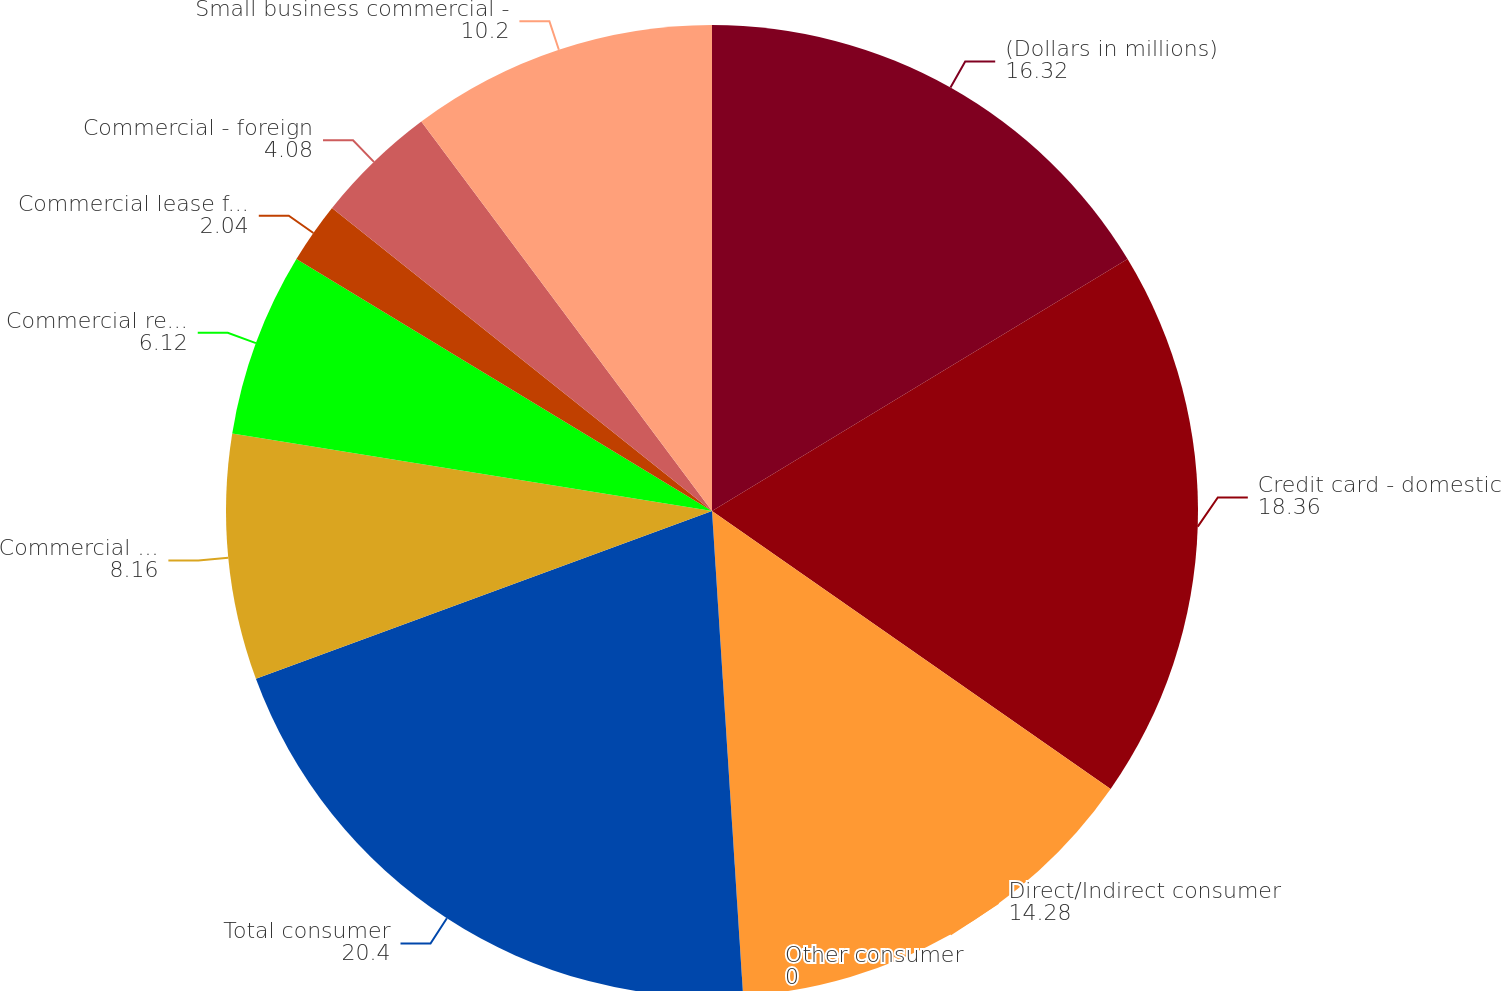<chart> <loc_0><loc_0><loc_500><loc_500><pie_chart><fcel>(Dollars in millions)<fcel>Credit card - domestic<fcel>Direct/Indirect consumer<fcel>Other consumer<fcel>Total consumer<fcel>Commercial - domestic (3)<fcel>Commercial real estate<fcel>Commercial lease financing<fcel>Commercial - foreign<fcel>Small business commercial -<nl><fcel>16.32%<fcel>18.36%<fcel>14.28%<fcel>0.0%<fcel>20.4%<fcel>8.16%<fcel>6.12%<fcel>2.04%<fcel>4.08%<fcel>10.2%<nl></chart> 